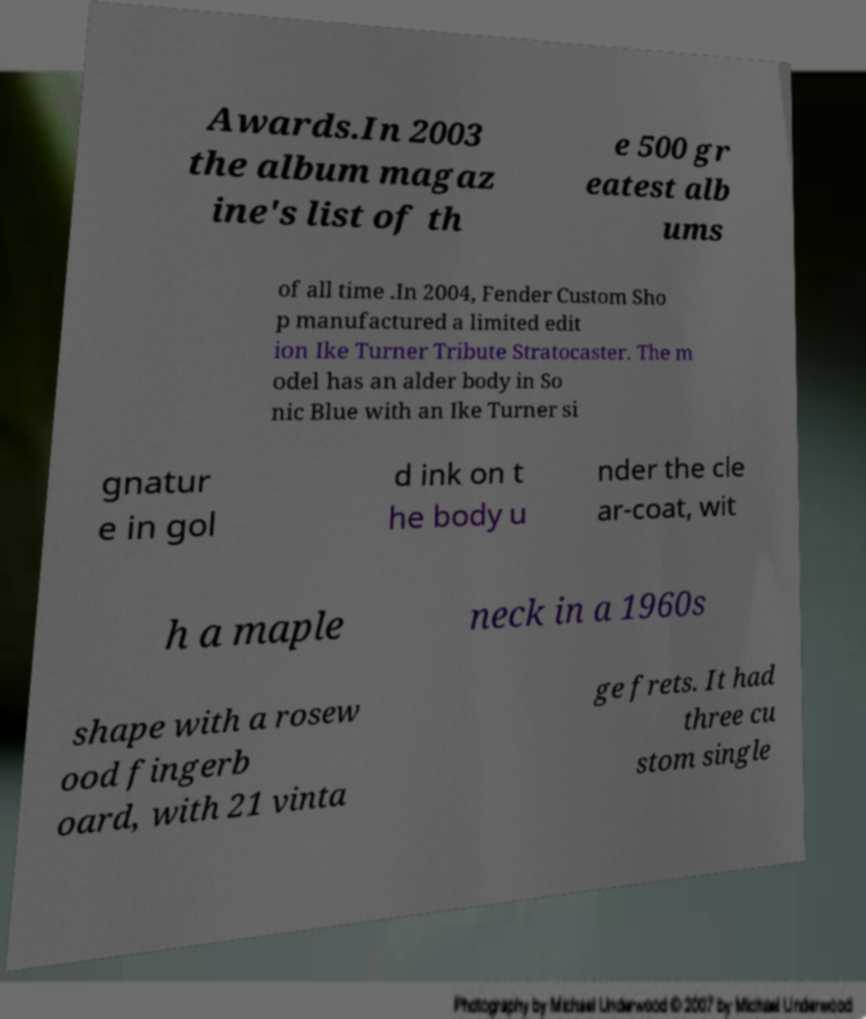Can you accurately transcribe the text from the provided image for me? Awards.In 2003 the album magaz ine's list of th e 500 gr eatest alb ums of all time .In 2004, Fender Custom Sho p manufactured a limited edit ion Ike Turner Tribute Stratocaster. The m odel has an alder body in So nic Blue with an Ike Turner si gnatur e in gol d ink on t he body u nder the cle ar-coat, wit h a maple neck in a 1960s shape with a rosew ood fingerb oard, with 21 vinta ge frets. It had three cu stom single 